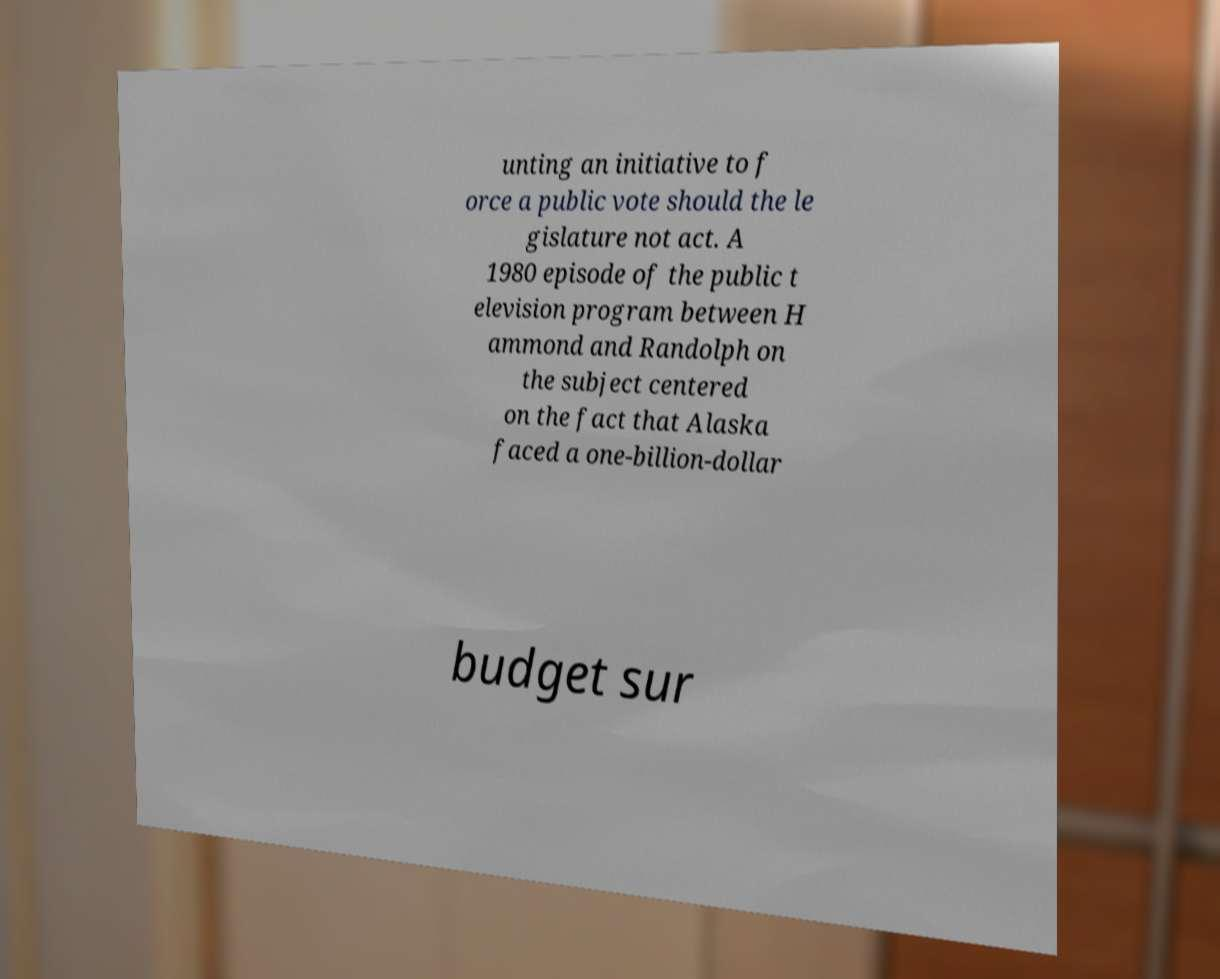I need the written content from this picture converted into text. Can you do that? unting an initiative to f orce a public vote should the le gislature not act. A 1980 episode of the public t elevision program between H ammond and Randolph on the subject centered on the fact that Alaska faced a one-billion-dollar budget sur 